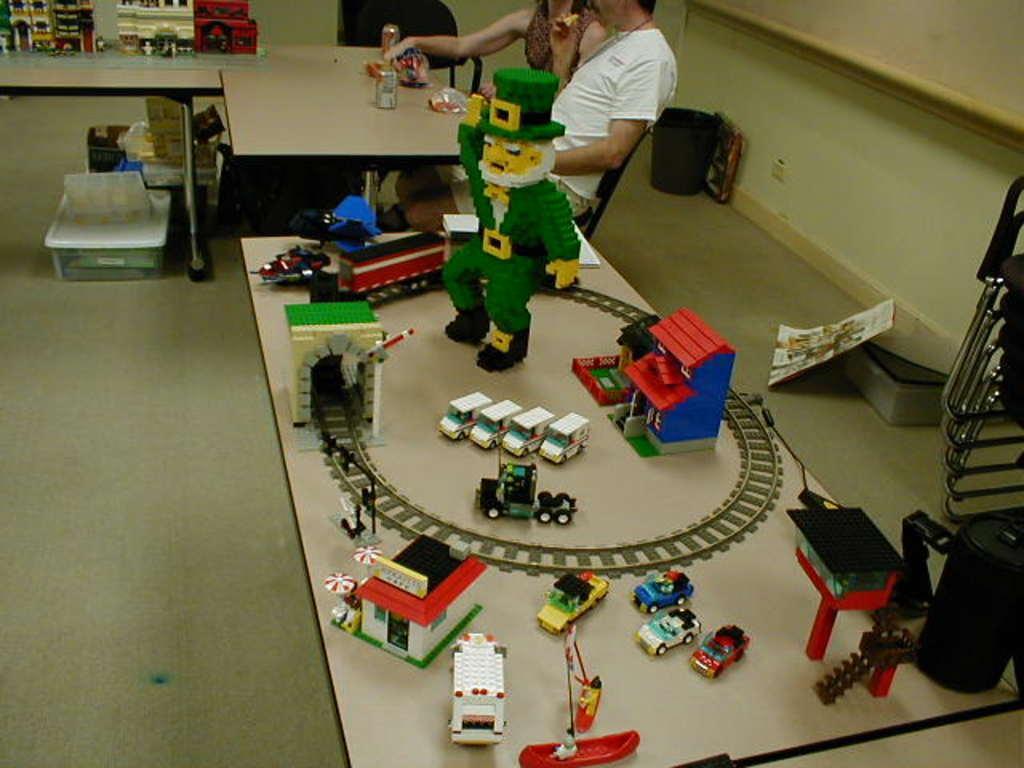Please provide a concise description of this image. In this there is a table on which there are lego toys on it. There is a man and woman sitting in the chair near the table. On the table there are cool drink tins and covers. On the floor there are dustbin,tray and box. 